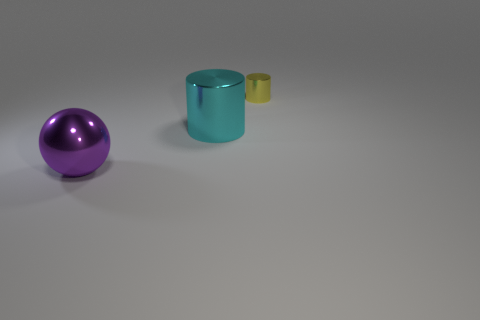Add 1 tiny yellow cylinders. How many objects exist? 4 Subtract all cyan cylinders. How many cylinders are left? 1 Subtract all balls. How many objects are left? 2 Add 1 small things. How many small things are left? 2 Add 3 big balls. How many big balls exist? 4 Subtract 0 blue cylinders. How many objects are left? 3 Subtract 1 cylinders. How many cylinders are left? 1 Subtract all purple cylinders. Subtract all gray cubes. How many cylinders are left? 2 Subtract all yellow spheres. How many red cylinders are left? 0 Subtract all small metal spheres. Subtract all yellow objects. How many objects are left? 2 